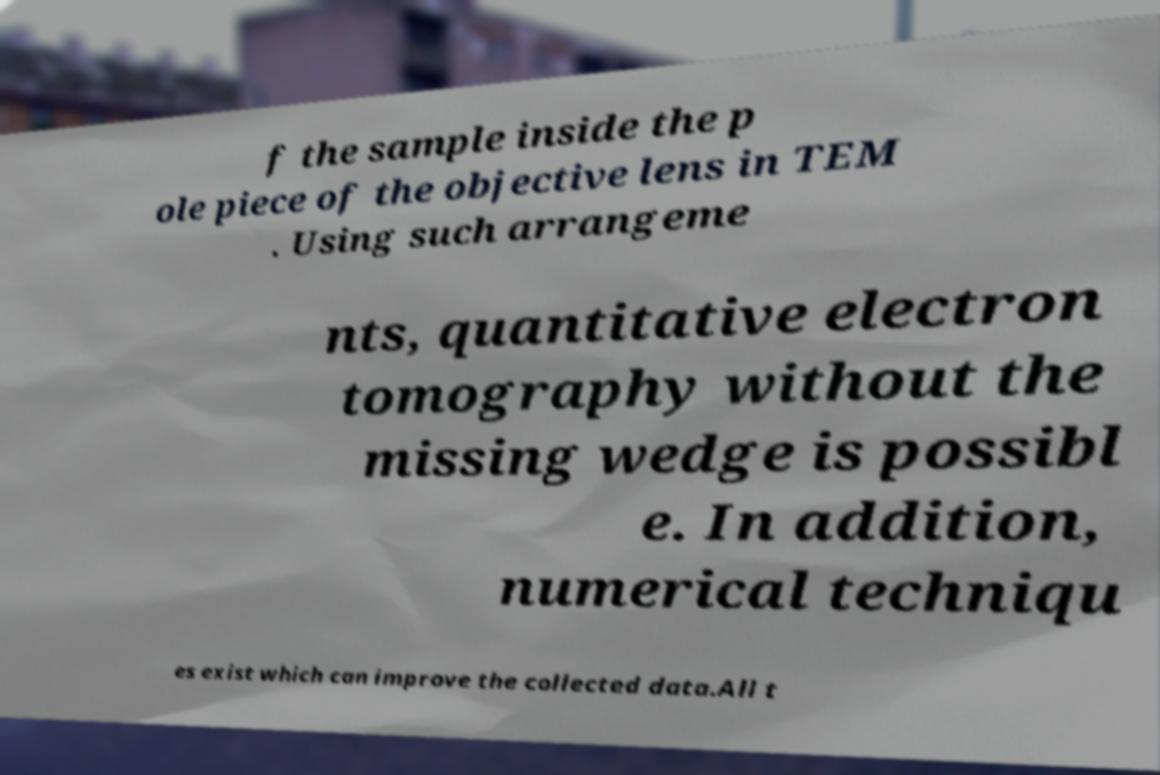Could you assist in decoding the text presented in this image and type it out clearly? f the sample inside the p ole piece of the objective lens in TEM . Using such arrangeme nts, quantitative electron tomography without the missing wedge is possibl e. In addition, numerical techniqu es exist which can improve the collected data.All t 